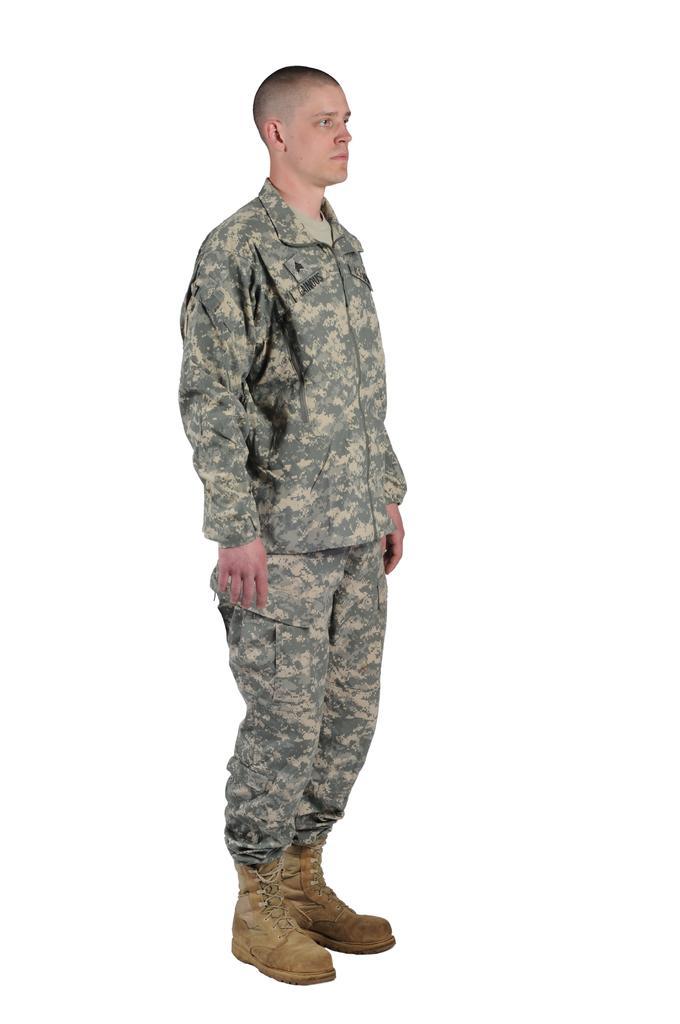Could you give a brief overview of what you see in this image? In this image we can see the person standing and there is the white background. 